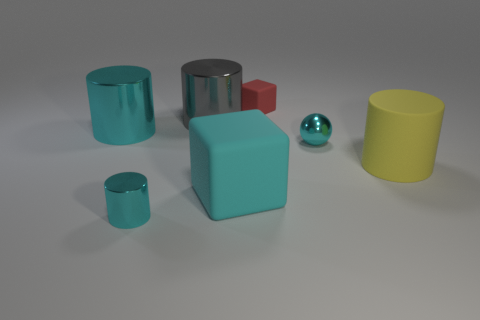Subtract 1 cylinders. How many cylinders are left? 3 Add 2 shiny objects. How many objects exist? 9 Subtract all cubes. How many objects are left? 5 Subtract 0 purple cylinders. How many objects are left? 7 Subtract all large yellow rubber things. Subtract all tiny cyan spheres. How many objects are left? 5 Add 6 large gray cylinders. How many large gray cylinders are left? 7 Add 4 shiny cylinders. How many shiny cylinders exist? 7 